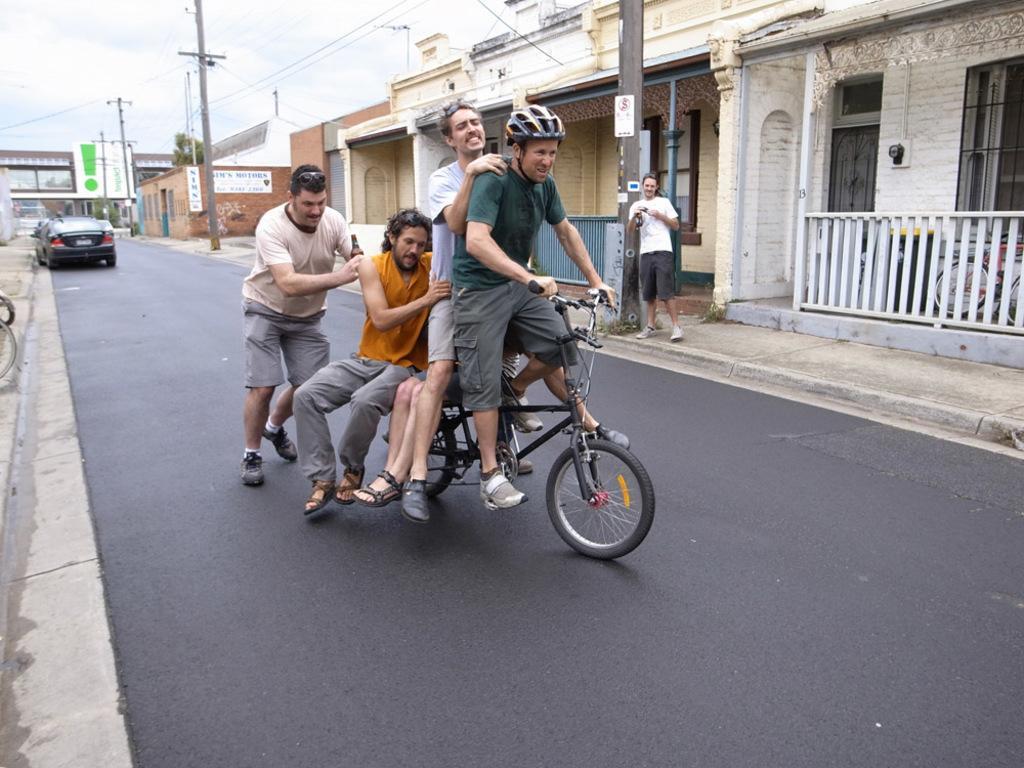Describe this image in one or two sentences. This picture is of outside. In the center we can see a man wearing green color t-shirt, helmet and riding a bicycle, behind him there is a group of person sitting on the bicycle and we can see a man seems to be walking. On the right we can see a building and a pole. There is a man wearing white color t-shirt and standing on the sidewalk. On the left there is a car which is black in color. In the background we can see the sky, full of clouds, poles, buildings and cables. 